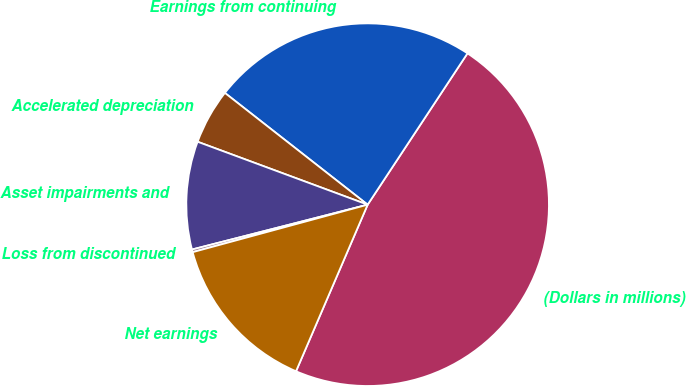Convert chart. <chart><loc_0><loc_0><loc_500><loc_500><pie_chart><fcel>(Dollars in millions)<fcel>Earnings from continuing<fcel>Accelerated depreciation<fcel>Asset impairments and<fcel>Loss from discontinued<fcel>Net earnings<nl><fcel>47.18%<fcel>23.71%<fcel>4.93%<fcel>9.62%<fcel>0.24%<fcel>14.32%<nl></chart> 